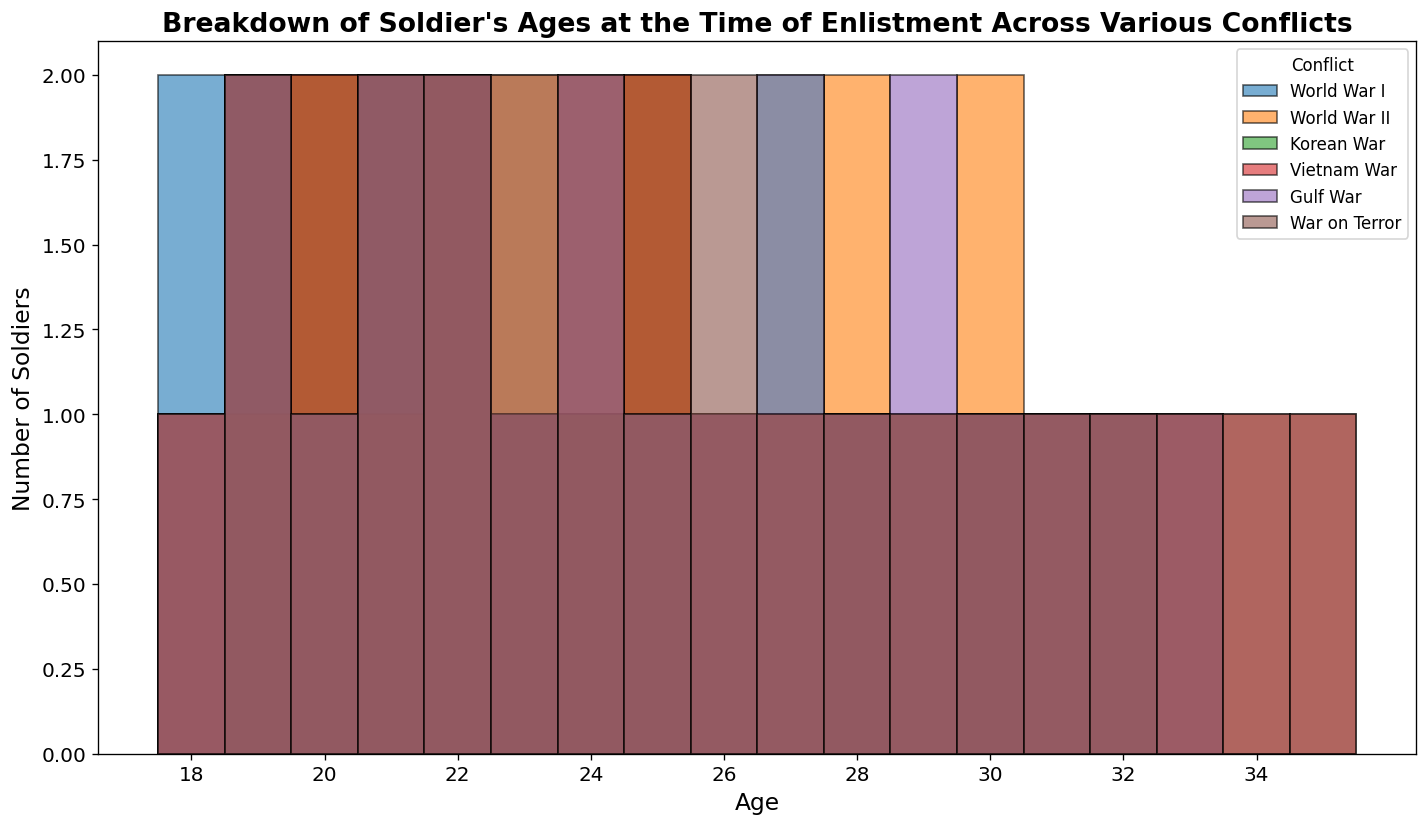What age group saw the highest number of enlistments during World War II? Look for the tallest bar in the histogram for World War II. Determine the corresponding age group of that bar.
Answer: 22 Which conflict had the youngest group of enlistees? Identify the histogram segment with the leftmost bars. Compare the ages of the youngest enlistees across different conflicts.
Answer: World War I What was the most common age for enlistment during the Korean War and the Vietnam War? Find the tallest bar in the Korean War section and note its age. Repeat for the Vietnam War section. Compare both ages.
Answer: 25 (Korean War), 20 (Vietnam War) Which conflict shows the greatest age diversity among enlistees? Assess the spread of the bars along the age axis for each conflict and identify which conflict covers the widest age range.
Answer: Vietnam War How do the enlistment age distributions for World War I and the Gulf War compare? Visually compare the bars for World War I and the Gulf War. Look for differences in height, peaks, and spread.
Answer: Similar peaks, but World War I is more concentrated around early 20s while the Gulf War has a wider age distribution What is the difference in the peak enlistment age between World War II and the War on Terror? Identify the tallest bar in World War II and note its age. Do the same for the War on Terror. Compute the difference between these ages.
Answer: 1 year Among the conflicts listed, which one has the highest number of soldiers enlisting at age 18? Locate the bar representing age 18 for each conflict and compare their heights to determine which is tallest.
Answer: World War I What are the three most common ages of enlistees overall? Combine all segments of the histogram across all conflicts and identify the three tallest bars, noting their corresponding ages.
Answer: 22, 20, 25 How often did soldiers aged 30 enlist in the Gulf War compared to the War on Terror? Compare the heights of the bars at age 30 for both the Gulf War and the War on Terror.
Answer: Fewer in the Gulf War than the War on Terror How does the age distribution of enlistees during World War II differ from the War on Terror in terms of spread and peak? Compare the spread of bars along the age axis and the height of the tallest bar (peak) for World War II and the War on Terror.
Answer: War on Terror has a wider spread, World War II has a higher peak at age 22 